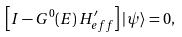Convert formula to latex. <formula><loc_0><loc_0><loc_500><loc_500>\left [ I - G ^ { 0 } ( E ) \, H ^ { \prime } _ { e f f } \right ] | \, \psi \rangle = 0 ,</formula> 